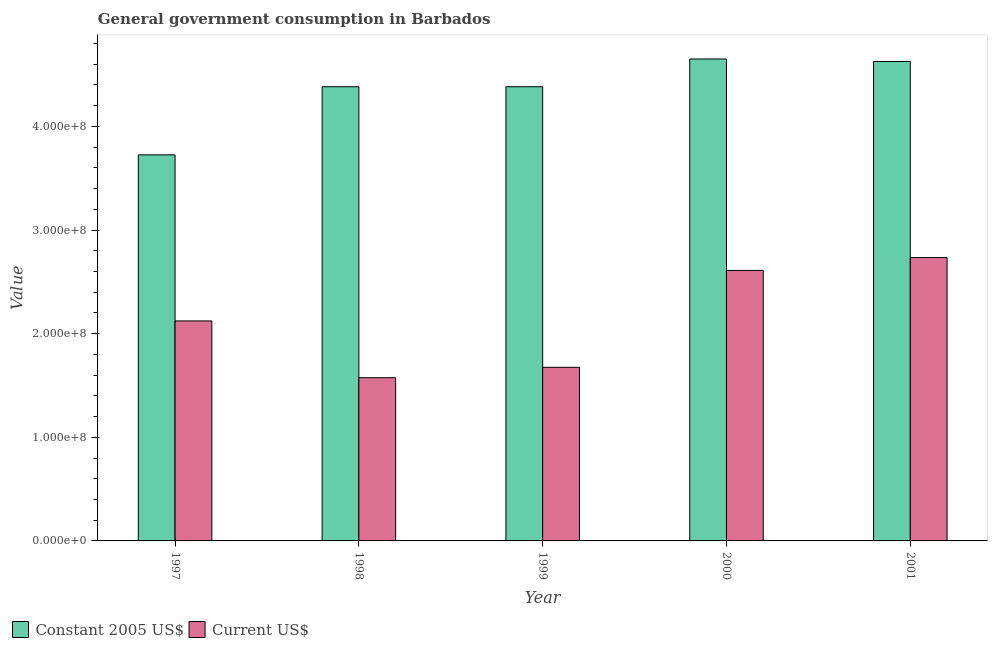How many different coloured bars are there?
Provide a succinct answer. 2. Are the number of bars per tick equal to the number of legend labels?
Your answer should be very brief. Yes. Are the number of bars on each tick of the X-axis equal?
Keep it short and to the point. Yes. How many bars are there on the 4th tick from the left?
Ensure brevity in your answer.  2. How many bars are there on the 4th tick from the right?
Make the answer very short. 2. What is the label of the 2nd group of bars from the left?
Provide a succinct answer. 1998. What is the value consumed in current us$ in 1999?
Your answer should be very brief. 1.68e+08. Across all years, what is the maximum value consumed in constant 2005 us$?
Make the answer very short. 4.65e+08. Across all years, what is the minimum value consumed in constant 2005 us$?
Your answer should be compact. 3.73e+08. In which year was the value consumed in current us$ minimum?
Keep it short and to the point. 1998. What is the total value consumed in constant 2005 us$ in the graph?
Your answer should be compact. 2.18e+09. What is the difference between the value consumed in constant 2005 us$ in 1998 and that in 2001?
Give a very brief answer. -2.44e+07. What is the difference between the value consumed in constant 2005 us$ in 2000 and the value consumed in current us$ in 1999?
Your answer should be compact. 2.68e+07. What is the average value consumed in current us$ per year?
Offer a terse response. 2.14e+08. In how many years, is the value consumed in current us$ greater than 220000000?
Make the answer very short. 2. What is the ratio of the value consumed in current us$ in 1999 to that in 2001?
Your answer should be very brief. 0.61. What is the difference between the highest and the second highest value consumed in current us$?
Provide a succinct answer. 1.24e+07. What is the difference between the highest and the lowest value consumed in constant 2005 us$?
Offer a terse response. 9.25e+07. In how many years, is the value consumed in current us$ greater than the average value consumed in current us$ taken over all years?
Keep it short and to the point. 2. What does the 1st bar from the left in 2001 represents?
Keep it short and to the point. Constant 2005 US$. What does the 1st bar from the right in 2000 represents?
Ensure brevity in your answer.  Current US$. How many bars are there?
Offer a terse response. 10. What is the difference between two consecutive major ticks on the Y-axis?
Ensure brevity in your answer.  1.00e+08. Are the values on the major ticks of Y-axis written in scientific E-notation?
Provide a short and direct response. Yes. Does the graph contain any zero values?
Ensure brevity in your answer.  No. Does the graph contain grids?
Provide a succinct answer. No. Where does the legend appear in the graph?
Offer a terse response. Bottom left. How many legend labels are there?
Keep it short and to the point. 2. How are the legend labels stacked?
Provide a succinct answer. Horizontal. What is the title of the graph?
Keep it short and to the point. General government consumption in Barbados. Does "Investment" appear as one of the legend labels in the graph?
Provide a short and direct response. No. What is the label or title of the X-axis?
Provide a succinct answer. Year. What is the label or title of the Y-axis?
Your answer should be very brief. Value. What is the Value of Constant 2005 US$ in 1997?
Make the answer very short. 3.73e+08. What is the Value in Current US$ in 1997?
Your answer should be very brief. 2.12e+08. What is the Value in Constant 2005 US$ in 1998?
Keep it short and to the point. 4.38e+08. What is the Value in Current US$ in 1998?
Your answer should be very brief. 1.58e+08. What is the Value of Constant 2005 US$ in 1999?
Your response must be concise. 4.38e+08. What is the Value in Current US$ in 1999?
Make the answer very short. 1.68e+08. What is the Value of Constant 2005 US$ in 2000?
Offer a terse response. 4.65e+08. What is the Value of Current US$ in 2000?
Offer a terse response. 2.61e+08. What is the Value in Constant 2005 US$ in 2001?
Provide a succinct answer. 4.63e+08. What is the Value of Current US$ in 2001?
Provide a succinct answer. 2.73e+08. Across all years, what is the maximum Value in Constant 2005 US$?
Offer a very short reply. 4.65e+08. Across all years, what is the maximum Value of Current US$?
Keep it short and to the point. 2.73e+08. Across all years, what is the minimum Value in Constant 2005 US$?
Your answer should be very brief. 3.73e+08. Across all years, what is the minimum Value in Current US$?
Make the answer very short. 1.58e+08. What is the total Value of Constant 2005 US$ in the graph?
Provide a short and direct response. 2.18e+09. What is the total Value in Current US$ in the graph?
Provide a short and direct response. 1.07e+09. What is the difference between the Value of Constant 2005 US$ in 1997 and that in 1998?
Give a very brief answer. -6.57e+07. What is the difference between the Value of Current US$ in 1997 and that in 1998?
Give a very brief answer. 5.48e+07. What is the difference between the Value in Constant 2005 US$ in 1997 and that in 1999?
Give a very brief answer. -6.57e+07. What is the difference between the Value of Current US$ in 1997 and that in 1999?
Give a very brief answer. 4.47e+07. What is the difference between the Value in Constant 2005 US$ in 1997 and that in 2000?
Your response must be concise. -9.25e+07. What is the difference between the Value in Current US$ in 1997 and that in 2000?
Give a very brief answer. -4.87e+07. What is the difference between the Value in Constant 2005 US$ in 1997 and that in 2001?
Keep it short and to the point. -9.01e+07. What is the difference between the Value of Current US$ in 1997 and that in 2001?
Provide a short and direct response. -6.12e+07. What is the difference between the Value in Current US$ in 1998 and that in 1999?
Provide a succinct answer. -1.01e+07. What is the difference between the Value in Constant 2005 US$ in 1998 and that in 2000?
Offer a very short reply. -2.68e+07. What is the difference between the Value of Current US$ in 1998 and that in 2000?
Make the answer very short. -1.04e+08. What is the difference between the Value in Constant 2005 US$ in 1998 and that in 2001?
Provide a succinct answer. -2.44e+07. What is the difference between the Value in Current US$ in 1998 and that in 2001?
Provide a succinct answer. -1.16e+08. What is the difference between the Value in Constant 2005 US$ in 1999 and that in 2000?
Provide a short and direct response. -2.68e+07. What is the difference between the Value of Current US$ in 1999 and that in 2000?
Provide a succinct answer. -9.35e+07. What is the difference between the Value in Constant 2005 US$ in 1999 and that in 2001?
Keep it short and to the point. -2.44e+07. What is the difference between the Value of Current US$ in 1999 and that in 2001?
Offer a terse response. -1.06e+08. What is the difference between the Value of Constant 2005 US$ in 2000 and that in 2001?
Give a very brief answer. 2.44e+06. What is the difference between the Value of Current US$ in 2000 and that in 2001?
Provide a succinct answer. -1.24e+07. What is the difference between the Value of Constant 2005 US$ in 1997 and the Value of Current US$ in 1998?
Make the answer very short. 2.15e+08. What is the difference between the Value of Constant 2005 US$ in 1997 and the Value of Current US$ in 1999?
Your answer should be compact. 2.05e+08. What is the difference between the Value in Constant 2005 US$ in 1997 and the Value in Current US$ in 2000?
Provide a succinct answer. 1.12e+08. What is the difference between the Value of Constant 2005 US$ in 1997 and the Value of Current US$ in 2001?
Give a very brief answer. 9.91e+07. What is the difference between the Value in Constant 2005 US$ in 1998 and the Value in Current US$ in 1999?
Your response must be concise. 2.71e+08. What is the difference between the Value in Constant 2005 US$ in 1998 and the Value in Current US$ in 2000?
Offer a very short reply. 1.77e+08. What is the difference between the Value in Constant 2005 US$ in 1998 and the Value in Current US$ in 2001?
Give a very brief answer. 1.65e+08. What is the difference between the Value in Constant 2005 US$ in 1999 and the Value in Current US$ in 2000?
Offer a very short reply. 1.77e+08. What is the difference between the Value in Constant 2005 US$ in 1999 and the Value in Current US$ in 2001?
Keep it short and to the point. 1.65e+08. What is the difference between the Value of Constant 2005 US$ in 2000 and the Value of Current US$ in 2001?
Give a very brief answer. 1.92e+08. What is the average Value of Constant 2005 US$ per year?
Offer a terse response. 4.35e+08. What is the average Value in Current US$ per year?
Provide a short and direct response. 2.14e+08. In the year 1997, what is the difference between the Value of Constant 2005 US$ and Value of Current US$?
Give a very brief answer. 1.60e+08. In the year 1998, what is the difference between the Value of Constant 2005 US$ and Value of Current US$?
Ensure brevity in your answer.  2.81e+08. In the year 1999, what is the difference between the Value of Constant 2005 US$ and Value of Current US$?
Provide a short and direct response. 2.71e+08. In the year 2000, what is the difference between the Value in Constant 2005 US$ and Value in Current US$?
Provide a short and direct response. 2.04e+08. In the year 2001, what is the difference between the Value of Constant 2005 US$ and Value of Current US$?
Make the answer very short. 1.89e+08. What is the ratio of the Value in Constant 2005 US$ in 1997 to that in 1998?
Your answer should be very brief. 0.85. What is the ratio of the Value of Current US$ in 1997 to that in 1998?
Your answer should be very brief. 1.35. What is the ratio of the Value in Constant 2005 US$ in 1997 to that in 1999?
Keep it short and to the point. 0.85. What is the ratio of the Value of Current US$ in 1997 to that in 1999?
Provide a succinct answer. 1.27. What is the ratio of the Value in Constant 2005 US$ in 1997 to that in 2000?
Offer a terse response. 0.8. What is the ratio of the Value in Current US$ in 1997 to that in 2000?
Give a very brief answer. 0.81. What is the ratio of the Value of Constant 2005 US$ in 1997 to that in 2001?
Give a very brief answer. 0.81. What is the ratio of the Value of Current US$ in 1997 to that in 2001?
Offer a terse response. 0.78. What is the ratio of the Value of Constant 2005 US$ in 1998 to that in 1999?
Make the answer very short. 1. What is the ratio of the Value in Constant 2005 US$ in 1998 to that in 2000?
Offer a terse response. 0.94. What is the ratio of the Value in Current US$ in 1998 to that in 2000?
Offer a terse response. 0.6. What is the ratio of the Value in Constant 2005 US$ in 1998 to that in 2001?
Provide a succinct answer. 0.95. What is the ratio of the Value of Current US$ in 1998 to that in 2001?
Offer a terse response. 0.58. What is the ratio of the Value in Constant 2005 US$ in 1999 to that in 2000?
Give a very brief answer. 0.94. What is the ratio of the Value of Current US$ in 1999 to that in 2000?
Your response must be concise. 0.64. What is the ratio of the Value in Current US$ in 1999 to that in 2001?
Offer a very short reply. 0.61. What is the ratio of the Value in Current US$ in 2000 to that in 2001?
Provide a short and direct response. 0.95. What is the difference between the highest and the second highest Value in Constant 2005 US$?
Provide a short and direct response. 2.44e+06. What is the difference between the highest and the second highest Value in Current US$?
Your response must be concise. 1.24e+07. What is the difference between the highest and the lowest Value in Constant 2005 US$?
Your response must be concise. 9.25e+07. What is the difference between the highest and the lowest Value in Current US$?
Your answer should be very brief. 1.16e+08. 